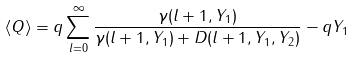Convert formula to latex. <formula><loc_0><loc_0><loc_500><loc_500>\langle Q \rangle = q \sum _ { l = 0 } ^ { \infty } \frac { \gamma ( l + 1 , Y _ { 1 } ) } { \gamma ( l + 1 , Y _ { 1 } ) + D ( l + 1 , Y _ { 1 } , Y _ { 2 } ) } - q Y _ { 1 }</formula> 